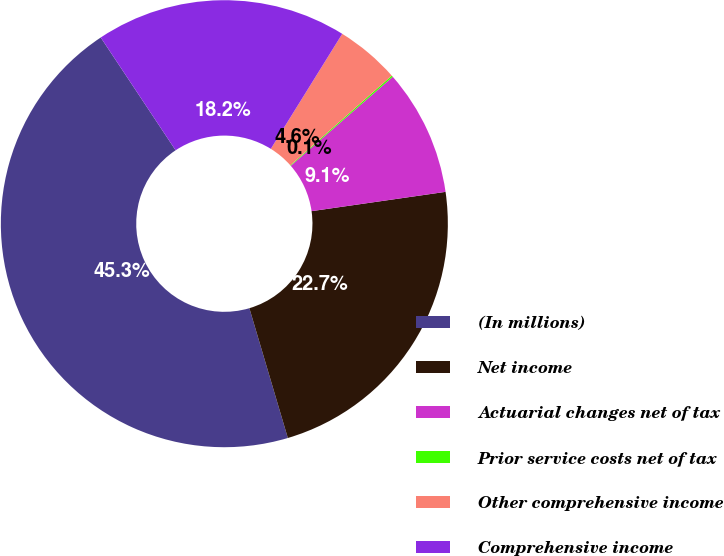<chart> <loc_0><loc_0><loc_500><loc_500><pie_chart><fcel>(In millions)<fcel>Net income<fcel>Actuarial changes net of tax<fcel>Prior service costs net of tax<fcel>Other comprehensive income<fcel>Comprehensive income<nl><fcel>45.26%<fcel>22.69%<fcel>9.14%<fcel>0.11%<fcel>4.63%<fcel>18.17%<nl></chart> 